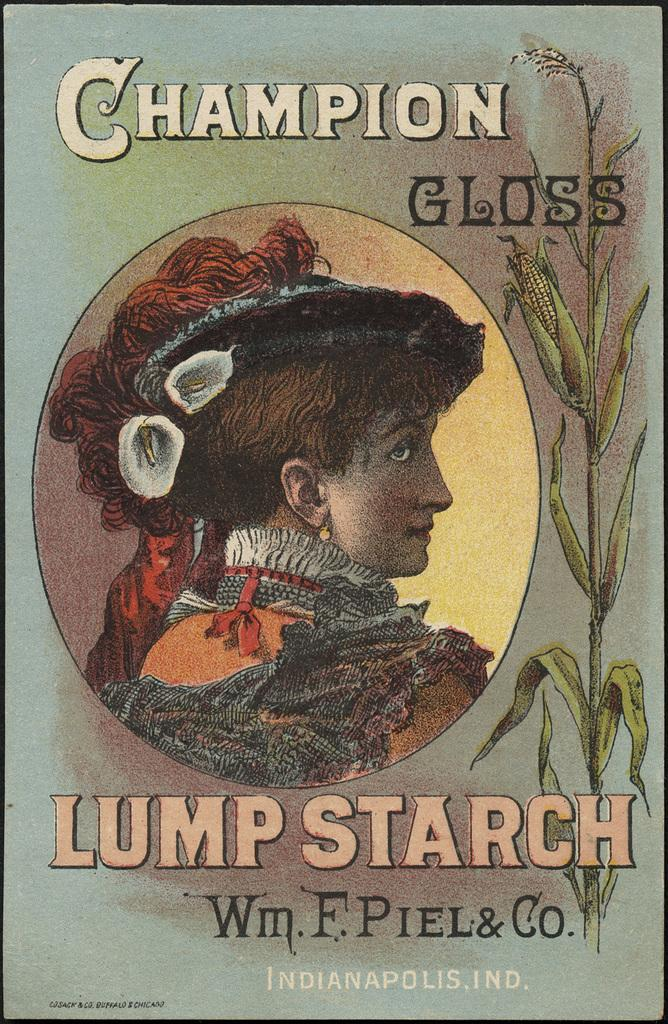<image>
Provide a brief description of the given image. An artistic depiction of the profile of a woman wearing a fancy hat and dress in an ad for Champion Gloss starch. 